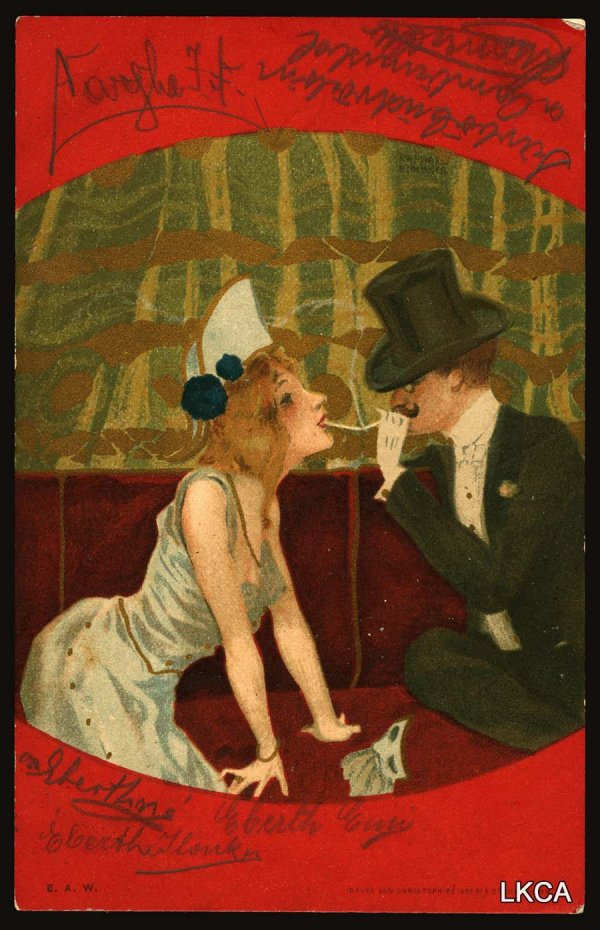Can you describe the emotions conveyed by this scene? The image conveys emotions of romance and tenderness. The intimate positioning of the man and woman, as they lean towards each other, suggests a close connection and mutual affection. The man's gentle posture and the woman's dreamy expression add to the romantic ambiance. The vibrant colors and artistic details further enhance the warmth and intimacy of the scene. 